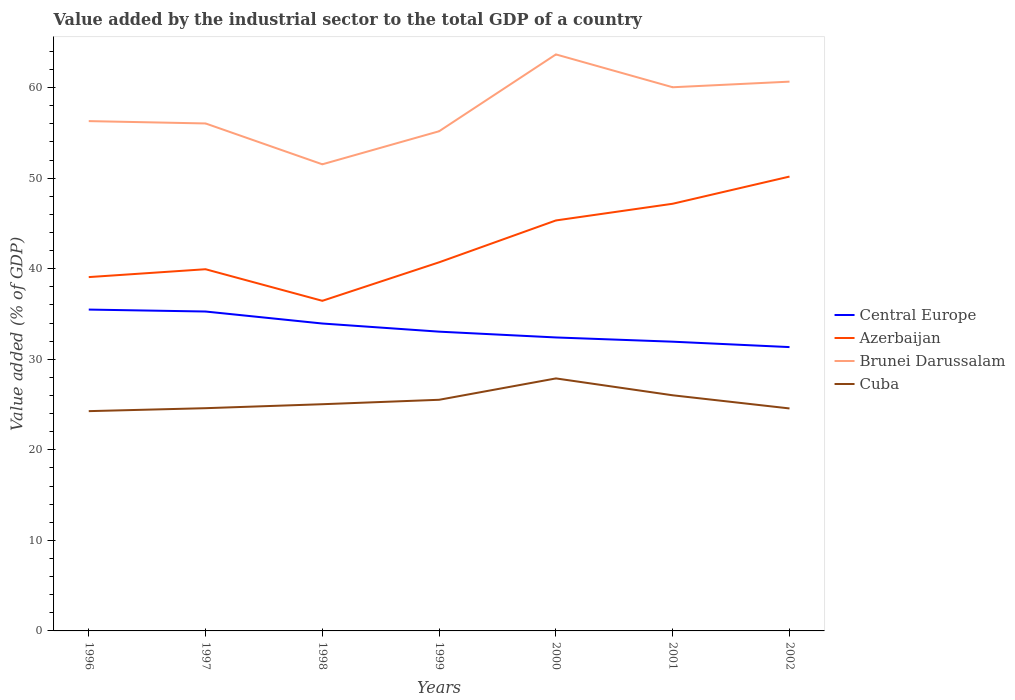Does the line corresponding to Brunei Darussalam intersect with the line corresponding to Central Europe?
Your answer should be compact. No. Across all years, what is the maximum value added by the industrial sector to the total GDP in Central Europe?
Your answer should be compact. 31.35. In which year was the value added by the industrial sector to the total GDP in Azerbaijan maximum?
Your answer should be very brief. 1998. What is the total value added by the industrial sector to the total GDP in Brunei Darussalam in the graph?
Ensure brevity in your answer.  4.77. What is the difference between the highest and the second highest value added by the industrial sector to the total GDP in Azerbaijan?
Offer a terse response. 13.72. What is the difference between the highest and the lowest value added by the industrial sector to the total GDP in Brunei Darussalam?
Provide a succinct answer. 3. Is the value added by the industrial sector to the total GDP in Brunei Darussalam strictly greater than the value added by the industrial sector to the total GDP in Cuba over the years?
Your response must be concise. No. What is the difference between two consecutive major ticks on the Y-axis?
Give a very brief answer. 10. Does the graph contain grids?
Ensure brevity in your answer.  No. Where does the legend appear in the graph?
Keep it short and to the point. Center right. How are the legend labels stacked?
Provide a short and direct response. Vertical. What is the title of the graph?
Provide a succinct answer. Value added by the industrial sector to the total GDP of a country. Does "United States" appear as one of the legend labels in the graph?
Offer a very short reply. No. What is the label or title of the X-axis?
Make the answer very short. Years. What is the label or title of the Y-axis?
Offer a very short reply. Value added (% of GDP). What is the Value added (% of GDP) of Central Europe in 1996?
Give a very brief answer. 35.49. What is the Value added (% of GDP) of Azerbaijan in 1996?
Give a very brief answer. 39.08. What is the Value added (% of GDP) of Brunei Darussalam in 1996?
Offer a very short reply. 56.3. What is the Value added (% of GDP) of Cuba in 1996?
Offer a very short reply. 24.27. What is the Value added (% of GDP) in Central Europe in 1997?
Offer a very short reply. 35.27. What is the Value added (% of GDP) in Azerbaijan in 1997?
Ensure brevity in your answer.  39.95. What is the Value added (% of GDP) in Brunei Darussalam in 1997?
Provide a short and direct response. 56.05. What is the Value added (% of GDP) of Cuba in 1997?
Ensure brevity in your answer.  24.6. What is the Value added (% of GDP) in Central Europe in 1998?
Offer a terse response. 33.95. What is the Value added (% of GDP) of Azerbaijan in 1998?
Provide a short and direct response. 36.46. What is the Value added (% of GDP) of Brunei Darussalam in 1998?
Provide a succinct answer. 51.53. What is the Value added (% of GDP) of Cuba in 1998?
Offer a very short reply. 25.04. What is the Value added (% of GDP) of Central Europe in 1999?
Your response must be concise. 33.05. What is the Value added (% of GDP) of Azerbaijan in 1999?
Give a very brief answer. 40.71. What is the Value added (% of GDP) of Brunei Darussalam in 1999?
Give a very brief answer. 55.18. What is the Value added (% of GDP) of Cuba in 1999?
Offer a terse response. 25.53. What is the Value added (% of GDP) in Central Europe in 2000?
Make the answer very short. 32.41. What is the Value added (% of GDP) of Azerbaijan in 2000?
Offer a terse response. 45.33. What is the Value added (% of GDP) of Brunei Darussalam in 2000?
Provide a short and direct response. 63.67. What is the Value added (% of GDP) in Cuba in 2000?
Provide a succinct answer. 27.89. What is the Value added (% of GDP) of Central Europe in 2001?
Provide a succinct answer. 31.94. What is the Value added (% of GDP) of Azerbaijan in 2001?
Your response must be concise. 47.18. What is the Value added (% of GDP) of Brunei Darussalam in 2001?
Keep it short and to the point. 60.04. What is the Value added (% of GDP) of Cuba in 2001?
Provide a succinct answer. 26.02. What is the Value added (% of GDP) in Central Europe in 2002?
Offer a very short reply. 31.35. What is the Value added (% of GDP) in Azerbaijan in 2002?
Offer a very short reply. 50.18. What is the Value added (% of GDP) of Brunei Darussalam in 2002?
Your answer should be very brief. 60.66. What is the Value added (% of GDP) in Cuba in 2002?
Provide a succinct answer. 24.57. Across all years, what is the maximum Value added (% of GDP) in Central Europe?
Give a very brief answer. 35.49. Across all years, what is the maximum Value added (% of GDP) in Azerbaijan?
Your response must be concise. 50.18. Across all years, what is the maximum Value added (% of GDP) of Brunei Darussalam?
Make the answer very short. 63.67. Across all years, what is the maximum Value added (% of GDP) in Cuba?
Offer a terse response. 27.89. Across all years, what is the minimum Value added (% of GDP) in Central Europe?
Your answer should be very brief. 31.35. Across all years, what is the minimum Value added (% of GDP) of Azerbaijan?
Provide a succinct answer. 36.46. Across all years, what is the minimum Value added (% of GDP) in Brunei Darussalam?
Provide a short and direct response. 51.53. Across all years, what is the minimum Value added (% of GDP) of Cuba?
Your response must be concise. 24.27. What is the total Value added (% of GDP) of Central Europe in the graph?
Offer a terse response. 233.47. What is the total Value added (% of GDP) of Azerbaijan in the graph?
Your answer should be very brief. 298.88. What is the total Value added (% of GDP) of Brunei Darussalam in the graph?
Give a very brief answer. 403.44. What is the total Value added (% of GDP) of Cuba in the graph?
Provide a succinct answer. 177.92. What is the difference between the Value added (% of GDP) in Central Europe in 1996 and that in 1997?
Your answer should be compact. 0.21. What is the difference between the Value added (% of GDP) of Azerbaijan in 1996 and that in 1997?
Ensure brevity in your answer.  -0.87. What is the difference between the Value added (% of GDP) of Brunei Darussalam in 1996 and that in 1997?
Provide a succinct answer. 0.26. What is the difference between the Value added (% of GDP) in Cuba in 1996 and that in 1997?
Offer a very short reply. -0.33. What is the difference between the Value added (% of GDP) of Central Europe in 1996 and that in 1998?
Ensure brevity in your answer.  1.54. What is the difference between the Value added (% of GDP) in Azerbaijan in 1996 and that in 1998?
Your response must be concise. 2.62. What is the difference between the Value added (% of GDP) of Brunei Darussalam in 1996 and that in 1998?
Ensure brevity in your answer.  4.77. What is the difference between the Value added (% of GDP) of Cuba in 1996 and that in 1998?
Offer a very short reply. -0.76. What is the difference between the Value added (% of GDP) of Central Europe in 1996 and that in 1999?
Ensure brevity in your answer.  2.44. What is the difference between the Value added (% of GDP) of Azerbaijan in 1996 and that in 1999?
Your answer should be compact. -1.63. What is the difference between the Value added (% of GDP) of Brunei Darussalam in 1996 and that in 1999?
Your response must be concise. 1.12. What is the difference between the Value added (% of GDP) of Cuba in 1996 and that in 1999?
Your answer should be very brief. -1.26. What is the difference between the Value added (% of GDP) in Central Europe in 1996 and that in 2000?
Offer a very short reply. 3.08. What is the difference between the Value added (% of GDP) in Azerbaijan in 1996 and that in 2000?
Your response must be concise. -6.26. What is the difference between the Value added (% of GDP) of Brunei Darussalam in 1996 and that in 2000?
Keep it short and to the point. -7.37. What is the difference between the Value added (% of GDP) of Cuba in 1996 and that in 2000?
Give a very brief answer. -3.61. What is the difference between the Value added (% of GDP) of Central Europe in 1996 and that in 2001?
Offer a terse response. 3.55. What is the difference between the Value added (% of GDP) of Azerbaijan in 1996 and that in 2001?
Offer a terse response. -8.1. What is the difference between the Value added (% of GDP) in Brunei Darussalam in 1996 and that in 2001?
Offer a terse response. -3.74. What is the difference between the Value added (% of GDP) in Cuba in 1996 and that in 2001?
Keep it short and to the point. -1.75. What is the difference between the Value added (% of GDP) in Central Europe in 1996 and that in 2002?
Provide a succinct answer. 4.14. What is the difference between the Value added (% of GDP) of Azerbaijan in 1996 and that in 2002?
Offer a terse response. -11.1. What is the difference between the Value added (% of GDP) in Brunei Darussalam in 1996 and that in 2002?
Your answer should be compact. -4.36. What is the difference between the Value added (% of GDP) in Cuba in 1996 and that in 2002?
Provide a short and direct response. -0.3. What is the difference between the Value added (% of GDP) in Central Europe in 1997 and that in 1998?
Your answer should be compact. 1.33. What is the difference between the Value added (% of GDP) of Azerbaijan in 1997 and that in 1998?
Ensure brevity in your answer.  3.49. What is the difference between the Value added (% of GDP) of Brunei Darussalam in 1997 and that in 1998?
Your answer should be compact. 4.51. What is the difference between the Value added (% of GDP) of Cuba in 1997 and that in 1998?
Give a very brief answer. -0.44. What is the difference between the Value added (% of GDP) of Central Europe in 1997 and that in 1999?
Provide a short and direct response. 2.22. What is the difference between the Value added (% of GDP) of Azerbaijan in 1997 and that in 1999?
Your response must be concise. -0.77. What is the difference between the Value added (% of GDP) in Brunei Darussalam in 1997 and that in 1999?
Make the answer very short. 0.86. What is the difference between the Value added (% of GDP) in Cuba in 1997 and that in 1999?
Your answer should be compact. -0.93. What is the difference between the Value added (% of GDP) of Central Europe in 1997 and that in 2000?
Provide a succinct answer. 2.86. What is the difference between the Value added (% of GDP) in Azerbaijan in 1997 and that in 2000?
Make the answer very short. -5.39. What is the difference between the Value added (% of GDP) in Brunei Darussalam in 1997 and that in 2000?
Make the answer very short. -7.62. What is the difference between the Value added (% of GDP) in Cuba in 1997 and that in 2000?
Provide a succinct answer. -3.29. What is the difference between the Value added (% of GDP) of Central Europe in 1997 and that in 2001?
Provide a short and direct response. 3.33. What is the difference between the Value added (% of GDP) in Azerbaijan in 1997 and that in 2001?
Provide a short and direct response. -7.23. What is the difference between the Value added (% of GDP) of Brunei Darussalam in 1997 and that in 2001?
Give a very brief answer. -4. What is the difference between the Value added (% of GDP) of Cuba in 1997 and that in 2001?
Offer a terse response. -1.43. What is the difference between the Value added (% of GDP) in Central Europe in 1997 and that in 2002?
Offer a terse response. 3.93. What is the difference between the Value added (% of GDP) of Azerbaijan in 1997 and that in 2002?
Make the answer very short. -10.23. What is the difference between the Value added (% of GDP) in Brunei Darussalam in 1997 and that in 2002?
Give a very brief answer. -4.62. What is the difference between the Value added (% of GDP) in Cuba in 1997 and that in 2002?
Make the answer very short. 0.03. What is the difference between the Value added (% of GDP) in Central Europe in 1998 and that in 1999?
Offer a terse response. 0.9. What is the difference between the Value added (% of GDP) of Azerbaijan in 1998 and that in 1999?
Provide a short and direct response. -4.25. What is the difference between the Value added (% of GDP) in Brunei Darussalam in 1998 and that in 1999?
Offer a very short reply. -3.65. What is the difference between the Value added (% of GDP) of Cuba in 1998 and that in 1999?
Your response must be concise. -0.49. What is the difference between the Value added (% of GDP) in Central Europe in 1998 and that in 2000?
Make the answer very short. 1.54. What is the difference between the Value added (% of GDP) of Azerbaijan in 1998 and that in 2000?
Offer a terse response. -8.88. What is the difference between the Value added (% of GDP) in Brunei Darussalam in 1998 and that in 2000?
Give a very brief answer. -12.14. What is the difference between the Value added (% of GDP) of Cuba in 1998 and that in 2000?
Offer a terse response. -2.85. What is the difference between the Value added (% of GDP) in Central Europe in 1998 and that in 2001?
Keep it short and to the point. 2.01. What is the difference between the Value added (% of GDP) of Azerbaijan in 1998 and that in 2001?
Make the answer very short. -10.72. What is the difference between the Value added (% of GDP) in Brunei Darussalam in 1998 and that in 2001?
Make the answer very short. -8.51. What is the difference between the Value added (% of GDP) in Cuba in 1998 and that in 2001?
Your answer should be compact. -0.99. What is the difference between the Value added (% of GDP) of Central Europe in 1998 and that in 2002?
Provide a succinct answer. 2.6. What is the difference between the Value added (% of GDP) of Azerbaijan in 1998 and that in 2002?
Provide a succinct answer. -13.72. What is the difference between the Value added (% of GDP) of Brunei Darussalam in 1998 and that in 2002?
Ensure brevity in your answer.  -9.13. What is the difference between the Value added (% of GDP) of Cuba in 1998 and that in 2002?
Ensure brevity in your answer.  0.47. What is the difference between the Value added (% of GDP) in Central Europe in 1999 and that in 2000?
Make the answer very short. 0.64. What is the difference between the Value added (% of GDP) in Azerbaijan in 1999 and that in 2000?
Make the answer very short. -4.62. What is the difference between the Value added (% of GDP) in Brunei Darussalam in 1999 and that in 2000?
Your answer should be compact. -8.49. What is the difference between the Value added (% of GDP) in Cuba in 1999 and that in 2000?
Provide a succinct answer. -2.36. What is the difference between the Value added (% of GDP) of Central Europe in 1999 and that in 2001?
Provide a short and direct response. 1.11. What is the difference between the Value added (% of GDP) of Azerbaijan in 1999 and that in 2001?
Make the answer very short. -6.47. What is the difference between the Value added (% of GDP) in Brunei Darussalam in 1999 and that in 2001?
Offer a very short reply. -4.86. What is the difference between the Value added (% of GDP) in Cuba in 1999 and that in 2001?
Offer a terse response. -0.5. What is the difference between the Value added (% of GDP) in Central Europe in 1999 and that in 2002?
Offer a terse response. 1.7. What is the difference between the Value added (% of GDP) in Azerbaijan in 1999 and that in 2002?
Your answer should be compact. -9.47. What is the difference between the Value added (% of GDP) of Brunei Darussalam in 1999 and that in 2002?
Provide a short and direct response. -5.48. What is the difference between the Value added (% of GDP) in Cuba in 1999 and that in 2002?
Your answer should be very brief. 0.96. What is the difference between the Value added (% of GDP) of Central Europe in 2000 and that in 2001?
Your answer should be compact. 0.47. What is the difference between the Value added (% of GDP) of Azerbaijan in 2000 and that in 2001?
Make the answer very short. -1.84. What is the difference between the Value added (% of GDP) of Brunei Darussalam in 2000 and that in 2001?
Give a very brief answer. 3.63. What is the difference between the Value added (% of GDP) in Cuba in 2000 and that in 2001?
Provide a short and direct response. 1.86. What is the difference between the Value added (% of GDP) in Central Europe in 2000 and that in 2002?
Offer a terse response. 1.06. What is the difference between the Value added (% of GDP) in Azerbaijan in 2000 and that in 2002?
Ensure brevity in your answer.  -4.85. What is the difference between the Value added (% of GDP) in Brunei Darussalam in 2000 and that in 2002?
Offer a very short reply. 3.01. What is the difference between the Value added (% of GDP) of Cuba in 2000 and that in 2002?
Ensure brevity in your answer.  3.32. What is the difference between the Value added (% of GDP) in Central Europe in 2001 and that in 2002?
Give a very brief answer. 0.6. What is the difference between the Value added (% of GDP) of Azerbaijan in 2001 and that in 2002?
Offer a very short reply. -3. What is the difference between the Value added (% of GDP) in Brunei Darussalam in 2001 and that in 2002?
Give a very brief answer. -0.62. What is the difference between the Value added (% of GDP) of Cuba in 2001 and that in 2002?
Make the answer very short. 1.45. What is the difference between the Value added (% of GDP) in Central Europe in 1996 and the Value added (% of GDP) in Azerbaijan in 1997?
Give a very brief answer. -4.46. What is the difference between the Value added (% of GDP) in Central Europe in 1996 and the Value added (% of GDP) in Brunei Darussalam in 1997?
Your answer should be very brief. -20.56. What is the difference between the Value added (% of GDP) of Central Europe in 1996 and the Value added (% of GDP) of Cuba in 1997?
Offer a very short reply. 10.89. What is the difference between the Value added (% of GDP) of Azerbaijan in 1996 and the Value added (% of GDP) of Brunei Darussalam in 1997?
Your answer should be very brief. -16.97. What is the difference between the Value added (% of GDP) of Azerbaijan in 1996 and the Value added (% of GDP) of Cuba in 1997?
Give a very brief answer. 14.48. What is the difference between the Value added (% of GDP) in Brunei Darussalam in 1996 and the Value added (% of GDP) in Cuba in 1997?
Your response must be concise. 31.71. What is the difference between the Value added (% of GDP) in Central Europe in 1996 and the Value added (% of GDP) in Azerbaijan in 1998?
Provide a short and direct response. -0.97. What is the difference between the Value added (% of GDP) of Central Europe in 1996 and the Value added (% of GDP) of Brunei Darussalam in 1998?
Provide a short and direct response. -16.04. What is the difference between the Value added (% of GDP) in Central Europe in 1996 and the Value added (% of GDP) in Cuba in 1998?
Your response must be concise. 10.45. What is the difference between the Value added (% of GDP) in Azerbaijan in 1996 and the Value added (% of GDP) in Brunei Darussalam in 1998?
Offer a very short reply. -12.46. What is the difference between the Value added (% of GDP) in Azerbaijan in 1996 and the Value added (% of GDP) in Cuba in 1998?
Make the answer very short. 14.04. What is the difference between the Value added (% of GDP) in Brunei Darussalam in 1996 and the Value added (% of GDP) in Cuba in 1998?
Offer a terse response. 31.27. What is the difference between the Value added (% of GDP) of Central Europe in 1996 and the Value added (% of GDP) of Azerbaijan in 1999?
Provide a short and direct response. -5.22. What is the difference between the Value added (% of GDP) of Central Europe in 1996 and the Value added (% of GDP) of Brunei Darussalam in 1999?
Provide a succinct answer. -19.69. What is the difference between the Value added (% of GDP) in Central Europe in 1996 and the Value added (% of GDP) in Cuba in 1999?
Ensure brevity in your answer.  9.96. What is the difference between the Value added (% of GDP) in Azerbaijan in 1996 and the Value added (% of GDP) in Brunei Darussalam in 1999?
Offer a very short reply. -16.11. What is the difference between the Value added (% of GDP) in Azerbaijan in 1996 and the Value added (% of GDP) in Cuba in 1999?
Your answer should be very brief. 13.55. What is the difference between the Value added (% of GDP) in Brunei Darussalam in 1996 and the Value added (% of GDP) in Cuba in 1999?
Provide a succinct answer. 30.78. What is the difference between the Value added (% of GDP) of Central Europe in 1996 and the Value added (% of GDP) of Azerbaijan in 2000?
Keep it short and to the point. -9.84. What is the difference between the Value added (% of GDP) in Central Europe in 1996 and the Value added (% of GDP) in Brunei Darussalam in 2000?
Your answer should be very brief. -28.18. What is the difference between the Value added (% of GDP) of Central Europe in 1996 and the Value added (% of GDP) of Cuba in 2000?
Provide a succinct answer. 7.6. What is the difference between the Value added (% of GDP) of Azerbaijan in 1996 and the Value added (% of GDP) of Brunei Darussalam in 2000?
Keep it short and to the point. -24.59. What is the difference between the Value added (% of GDP) of Azerbaijan in 1996 and the Value added (% of GDP) of Cuba in 2000?
Your response must be concise. 11.19. What is the difference between the Value added (% of GDP) of Brunei Darussalam in 1996 and the Value added (% of GDP) of Cuba in 2000?
Your answer should be compact. 28.42. What is the difference between the Value added (% of GDP) in Central Europe in 1996 and the Value added (% of GDP) in Azerbaijan in 2001?
Ensure brevity in your answer.  -11.69. What is the difference between the Value added (% of GDP) of Central Europe in 1996 and the Value added (% of GDP) of Brunei Darussalam in 2001?
Offer a very short reply. -24.55. What is the difference between the Value added (% of GDP) in Central Europe in 1996 and the Value added (% of GDP) in Cuba in 2001?
Provide a short and direct response. 9.47. What is the difference between the Value added (% of GDP) of Azerbaijan in 1996 and the Value added (% of GDP) of Brunei Darussalam in 2001?
Give a very brief answer. -20.97. What is the difference between the Value added (% of GDP) in Azerbaijan in 1996 and the Value added (% of GDP) in Cuba in 2001?
Make the answer very short. 13.05. What is the difference between the Value added (% of GDP) of Brunei Darussalam in 1996 and the Value added (% of GDP) of Cuba in 2001?
Your answer should be compact. 30.28. What is the difference between the Value added (% of GDP) in Central Europe in 1996 and the Value added (% of GDP) in Azerbaijan in 2002?
Ensure brevity in your answer.  -14.69. What is the difference between the Value added (% of GDP) of Central Europe in 1996 and the Value added (% of GDP) of Brunei Darussalam in 2002?
Provide a succinct answer. -25.17. What is the difference between the Value added (% of GDP) of Central Europe in 1996 and the Value added (% of GDP) of Cuba in 2002?
Ensure brevity in your answer.  10.92. What is the difference between the Value added (% of GDP) in Azerbaijan in 1996 and the Value added (% of GDP) in Brunei Darussalam in 2002?
Ensure brevity in your answer.  -21.58. What is the difference between the Value added (% of GDP) of Azerbaijan in 1996 and the Value added (% of GDP) of Cuba in 2002?
Provide a short and direct response. 14.51. What is the difference between the Value added (% of GDP) in Brunei Darussalam in 1996 and the Value added (% of GDP) in Cuba in 2002?
Keep it short and to the point. 31.73. What is the difference between the Value added (% of GDP) of Central Europe in 1997 and the Value added (% of GDP) of Azerbaijan in 1998?
Offer a terse response. -1.18. What is the difference between the Value added (% of GDP) of Central Europe in 1997 and the Value added (% of GDP) of Brunei Darussalam in 1998?
Provide a short and direct response. -16.26. What is the difference between the Value added (% of GDP) in Central Europe in 1997 and the Value added (% of GDP) in Cuba in 1998?
Give a very brief answer. 10.24. What is the difference between the Value added (% of GDP) of Azerbaijan in 1997 and the Value added (% of GDP) of Brunei Darussalam in 1998?
Provide a succinct answer. -11.59. What is the difference between the Value added (% of GDP) in Azerbaijan in 1997 and the Value added (% of GDP) in Cuba in 1998?
Give a very brief answer. 14.91. What is the difference between the Value added (% of GDP) of Brunei Darussalam in 1997 and the Value added (% of GDP) of Cuba in 1998?
Provide a succinct answer. 31.01. What is the difference between the Value added (% of GDP) in Central Europe in 1997 and the Value added (% of GDP) in Azerbaijan in 1999?
Make the answer very short. -5.44. What is the difference between the Value added (% of GDP) of Central Europe in 1997 and the Value added (% of GDP) of Brunei Darussalam in 1999?
Give a very brief answer. -19.91. What is the difference between the Value added (% of GDP) of Central Europe in 1997 and the Value added (% of GDP) of Cuba in 1999?
Give a very brief answer. 9.75. What is the difference between the Value added (% of GDP) in Azerbaijan in 1997 and the Value added (% of GDP) in Brunei Darussalam in 1999?
Provide a short and direct response. -15.24. What is the difference between the Value added (% of GDP) of Azerbaijan in 1997 and the Value added (% of GDP) of Cuba in 1999?
Ensure brevity in your answer.  14.42. What is the difference between the Value added (% of GDP) of Brunei Darussalam in 1997 and the Value added (% of GDP) of Cuba in 1999?
Ensure brevity in your answer.  30.52. What is the difference between the Value added (% of GDP) of Central Europe in 1997 and the Value added (% of GDP) of Azerbaijan in 2000?
Provide a short and direct response. -10.06. What is the difference between the Value added (% of GDP) in Central Europe in 1997 and the Value added (% of GDP) in Brunei Darussalam in 2000?
Ensure brevity in your answer.  -28.39. What is the difference between the Value added (% of GDP) of Central Europe in 1997 and the Value added (% of GDP) of Cuba in 2000?
Give a very brief answer. 7.39. What is the difference between the Value added (% of GDP) of Azerbaijan in 1997 and the Value added (% of GDP) of Brunei Darussalam in 2000?
Keep it short and to the point. -23.72. What is the difference between the Value added (% of GDP) in Azerbaijan in 1997 and the Value added (% of GDP) in Cuba in 2000?
Offer a terse response. 12.06. What is the difference between the Value added (% of GDP) of Brunei Darussalam in 1997 and the Value added (% of GDP) of Cuba in 2000?
Make the answer very short. 28.16. What is the difference between the Value added (% of GDP) in Central Europe in 1997 and the Value added (% of GDP) in Azerbaijan in 2001?
Your answer should be compact. -11.9. What is the difference between the Value added (% of GDP) in Central Europe in 1997 and the Value added (% of GDP) in Brunei Darussalam in 2001?
Ensure brevity in your answer.  -24.77. What is the difference between the Value added (% of GDP) in Central Europe in 1997 and the Value added (% of GDP) in Cuba in 2001?
Keep it short and to the point. 9.25. What is the difference between the Value added (% of GDP) in Azerbaijan in 1997 and the Value added (% of GDP) in Brunei Darussalam in 2001?
Make the answer very short. -20.1. What is the difference between the Value added (% of GDP) of Azerbaijan in 1997 and the Value added (% of GDP) of Cuba in 2001?
Your response must be concise. 13.92. What is the difference between the Value added (% of GDP) of Brunei Darussalam in 1997 and the Value added (% of GDP) of Cuba in 2001?
Your response must be concise. 30.02. What is the difference between the Value added (% of GDP) in Central Europe in 1997 and the Value added (% of GDP) in Azerbaijan in 2002?
Your answer should be compact. -14.9. What is the difference between the Value added (% of GDP) in Central Europe in 1997 and the Value added (% of GDP) in Brunei Darussalam in 2002?
Give a very brief answer. -25.39. What is the difference between the Value added (% of GDP) of Central Europe in 1997 and the Value added (% of GDP) of Cuba in 2002?
Provide a succinct answer. 10.7. What is the difference between the Value added (% of GDP) of Azerbaijan in 1997 and the Value added (% of GDP) of Brunei Darussalam in 2002?
Provide a short and direct response. -20.72. What is the difference between the Value added (% of GDP) of Azerbaijan in 1997 and the Value added (% of GDP) of Cuba in 2002?
Ensure brevity in your answer.  15.38. What is the difference between the Value added (% of GDP) in Brunei Darussalam in 1997 and the Value added (% of GDP) in Cuba in 2002?
Your response must be concise. 31.48. What is the difference between the Value added (% of GDP) of Central Europe in 1998 and the Value added (% of GDP) of Azerbaijan in 1999?
Provide a short and direct response. -6.76. What is the difference between the Value added (% of GDP) in Central Europe in 1998 and the Value added (% of GDP) in Brunei Darussalam in 1999?
Your answer should be very brief. -21.23. What is the difference between the Value added (% of GDP) of Central Europe in 1998 and the Value added (% of GDP) of Cuba in 1999?
Ensure brevity in your answer.  8.42. What is the difference between the Value added (% of GDP) in Azerbaijan in 1998 and the Value added (% of GDP) in Brunei Darussalam in 1999?
Your response must be concise. -18.73. What is the difference between the Value added (% of GDP) in Azerbaijan in 1998 and the Value added (% of GDP) in Cuba in 1999?
Offer a terse response. 10.93. What is the difference between the Value added (% of GDP) in Brunei Darussalam in 1998 and the Value added (% of GDP) in Cuba in 1999?
Give a very brief answer. 26.01. What is the difference between the Value added (% of GDP) in Central Europe in 1998 and the Value added (% of GDP) in Azerbaijan in 2000?
Make the answer very short. -11.38. What is the difference between the Value added (% of GDP) in Central Europe in 1998 and the Value added (% of GDP) in Brunei Darussalam in 2000?
Keep it short and to the point. -29.72. What is the difference between the Value added (% of GDP) of Central Europe in 1998 and the Value added (% of GDP) of Cuba in 2000?
Offer a terse response. 6.06. What is the difference between the Value added (% of GDP) of Azerbaijan in 1998 and the Value added (% of GDP) of Brunei Darussalam in 2000?
Offer a very short reply. -27.21. What is the difference between the Value added (% of GDP) of Azerbaijan in 1998 and the Value added (% of GDP) of Cuba in 2000?
Keep it short and to the point. 8.57. What is the difference between the Value added (% of GDP) of Brunei Darussalam in 1998 and the Value added (% of GDP) of Cuba in 2000?
Keep it short and to the point. 23.65. What is the difference between the Value added (% of GDP) in Central Europe in 1998 and the Value added (% of GDP) in Azerbaijan in 2001?
Keep it short and to the point. -13.23. What is the difference between the Value added (% of GDP) in Central Europe in 1998 and the Value added (% of GDP) in Brunei Darussalam in 2001?
Keep it short and to the point. -26.09. What is the difference between the Value added (% of GDP) in Central Europe in 1998 and the Value added (% of GDP) in Cuba in 2001?
Your answer should be very brief. 7.93. What is the difference between the Value added (% of GDP) of Azerbaijan in 1998 and the Value added (% of GDP) of Brunei Darussalam in 2001?
Offer a very short reply. -23.59. What is the difference between the Value added (% of GDP) in Azerbaijan in 1998 and the Value added (% of GDP) in Cuba in 2001?
Keep it short and to the point. 10.43. What is the difference between the Value added (% of GDP) of Brunei Darussalam in 1998 and the Value added (% of GDP) of Cuba in 2001?
Offer a very short reply. 25.51. What is the difference between the Value added (% of GDP) of Central Europe in 1998 and the Value added (% of GDP) of Azerbaijan in 2002?
Keep it short and to the point. -16.23. What is the difference between the Value added (% of GDP) in Central Europe in 1998 and the Value added (% of GDP) in Brunei Darussalam in 2002?
Provide a short and direct response. -26.71. What is the difference between the Value added (% of GDP) in Central Europe in 1998 and the Value added (% of GDP) in Cuba in 2002?
Provide a short and direct response. 9.38. What is the difference between the Value added (% of GDP) in Azerbaijan in 1998 and the Value added (% of GDP) in Brunei Darussalam in 2002?
Ensure brevity in your answer.  -24.21. What is the difference between the Value added (% of GDP) of Azerbaijan in 1998 and the Value added (% of GDP) of Cuba in 2002?
Make the answer very short. 11.89. What is the difference between the Value added (% of GDP) of Brunei Darussalam in 1998 and the Value added (% of GDP) of Cuba in 2002?
Provide a short and direct response. 26.96. What is the difference between the Value added (% of GDP) of Central Europe in 1999 and the Value added (% of GDP) of Azerbaijan in 2000?
Your answer should be compact. -12.28. What is the difference between the Value added (% of GDP) of Central Europe in 1999 and the Value added (% of GDP) of Brunei Darussalam in 2000?
Make the answer very short. -30.62. What is the difference between the Value added (% of GDP) of Central Europe in 1999 and the Value added (% of GDP) of Cuba in 2000?
Keep it short and to the point. 5.16. What is the difference between the Value added (% of GDP) of Azerbaijan in 1999 and the Value added (% of GDP) of Brunei Darussalam in 2000?
Offer a terse response. -22.96. What is the difference between the Value added (% of GDP) in Azerbaijan in 1999 and the Value added (% of GDP) in Cuba in 2000?
Provide a succinct answer. 12.82. What is the difference between the Value added (% of GDP) in Brunei Darussalam in 1999 and the Value added (% of GDP) in Cuba in 2000?
Ensure brevity in your answer.  27.3. What is the difference between the Value added (% of GDP) in Central Europe in 1999 and the Value added (% of GDP) in Azerbaijan in 2001?
Make the answer very short. -14.13. What is the difference between the Value added (% of GDP) in Central Europe in 1999 and the Value added (% of GDP) in Brunei Darussalam in 2001?
Provide a succinct answer. -26.99. What is the difference between the Value added (% of GDP) in Central Europe in 1999 and the Value added (% of GDP) in Cuba in 2001?
Ensure brevity in your answer.  7.03. What is the difference between the Value added (% of GDP) in Azerbaijan in 1999 and the Value added (% of GDP) in Brunei Darussalam in 2001?
Offer a terse response. -19.33. What is the difference between the Value added (% of GDP) of Azerbaijan in 1999 and the Value added (% of GDP) of Cuba in 2001?
Offer a very short reply. 14.69. What is the difference between the Value added (% of GDP) in Brunei Darussalam in 1999 and the Value added (% of GDP) in Cuba in 2001?
Offer a terse response. 29.16. What is the difference between the Value added (% of GDP) of Central Europe in 1999 and the Value added (% of GDP) of Azerbaijan in 2002?
Make the answer very short. -17.13. What is the difference between the Value added (% of GDP) of Central Europe in 1999 and the Value added (% of GDP) of Brunei Darussalam in 2002?
Offer a terse response. -27.61. What is the difference between the Value added (% of GDP) of Central Europe in 1999 and the Value added (% of GDP) of Cuba in 2002?
Provide a succinct answer. 8.48. What is the difference between the Value added (% of GDP) of Azerbaijan in 1999 and the Value added (% of GDP) of Brunei Darussalam in 2002?
Your answer should be very brief. -19.95. What is the difference between the Value added (% of GDP) of Azerbaijan in 1999 and the Value added (% of GDP) of Cuba in 2002?
Make the answer very short. 16.14. What is the difference between the Value added (% of GDP) of Brunei Darussalam in 1999 and the Value added (% of GDP) of Cuba in 2002?
Keep it short and to the point. 30.61. What is the difference between the Value added (% of GDP) of Central Europe in 2000 and the Value added (% of GDP) of Azerbaijan in 2001?
Your response must be concise. -14.77. What is the difference between the Value added (% of GDP) of Central Europe in 2000 and the Value added (% of GDP) of Brunei Darussalam in 2001?
Your answer should be very brief. -27.63. What is the difference between the Value added (% of GDP) in Central Europe in 2000 and the Value added (% of GDP) in Cuba in 2001?
Provide a short and direct response. 6.39. What is the difference between the Value added (% of GDP) of Azerbaijan in 2000 and the Value added (% of GDP) of Brunei Darussalam in 2001?
Keep it short and to the point. -14.71. What is the difference between the Value added (% of GDP) of Azerbaijan in 2000 and the Value added (% of GDP) of Cuba in 2001?
Provide a short and direct response. 19.31. What is the difference between the Value added (% of GDP) in Brunei Darussalam in 2000 and the Value added (% of GDP) in Cuba in 2001?
Make the answer very short. 37.65. What is the difference between the Value added (% of GDP) in Central Europe in 2000 and the Value added (% of GDP) in Azerbaijan in 2002?
Your answer should be very brief. -17.77. What is the difference between the Value added (% of GDP) of Central Europe in 2000 and the Value added (% of GDP) of Brunei Darussalam in 2002?
Provide a short and direct response. -28.25. What is the difference between the Value added (% of GDP) in Central Europe in 2000 and the Value added (% of GDP) in Cuba in 2002?
Provide a succinct answer. 7.84. What is the difference between the Value added (% of GDP) of Azerbaijan in 2000 and the Value added (% of GDP) of Brunei Darussalam in 2002?
Give a very brief answer. -15.33. What is the difference between the Value added (% of GDP) in Azerbaijan in 2000 and the Value added (% of GDP) in Cuba in 2002?
Give a very brief answer. 20.76. What is the difference between the Value added (% of GDP) in Brunei Darussalam in 2000 and the Value added (% of GDP) in Cuba in 2002?
Offer a very short reply. 39.1. What is the difference between the Value added (% of GDP) of Central Europe in 2001 and the Value added (% of GDP) of Azerbaijan in 2002?
Offer a terse response. -18.23. What is the difference between the Value added (% of GDP) of Central Europe in 2001 and the Value added (% of GDP) of Brunei Darussalam in 2002?
Make the answer very short. -28.72. What is the difference between the Value added (% of GDP) of Central Europe in 2001 and the Value added (% of GDP) of Cuba in 2002?
Ensure brevity in your answer.  7.37. What is the difference between the Value added (% of GDP) in Azerbaijan in 2001 and the Value added (% of GDP) in Brunei Darussalam in 2002?
Give a very brief answer. -13.48. What is the difference between the Value added (% of GDP) of Azerbaijan in 2001 and the Value added (% of GDP) of Cuba in 2002?
Your response must be concise. 22.61. What is the difference between the Value added (% of GDP) of Brunei Darussalam in 2001 and the Value added (% of GDP) of Cuba in 2002?
Ensure brevity in your answer.  35.47. What is the average Value added (% of GDP) of Central Europe per year?
Give a very brief answer. 33.35. What is the average Value added (% of GDP) of Azerbaijan per year?
Ensure brevity in your answer.  42.7. What is the average Value added (% of GDP) in Brunei Darussalam per year?
Offer a very short reply. 57.63. What is the average Value added (% of GDP) in Cuba per year?
Make the answer very short. 25.42. In the year 1996, what is the difference between the Value added (% of GDP) in Central Europe and Value added (% of GDP) in Azerbaijan?
Your answer should be very brief. -3.59. In the year 1996, what is the difference between the Value added (% of GDP) in Central Europe and Value added (% of GDP) in Brunei Darussalam?
Provide a succinct answer. -20.81. In the year 1996, what is the difference between the Value added (% of GDP) in Central Europe and Value added (% of GDP) in Cuba?
Keep it short and to the point. 11.22. In the year 1996, what is the difference between the Value added (% of GDP) of Azerbaijan and Value added (% of GDP) of Brunei Darussalam?
Your answer should be compact. -17.23. In the year 1996, what is the difference between the Value added (% of GDP) of Azerbaijan and Value added (% of GDP) of Cuba?
Provide a short and direct response. 14.8. In the year 1996, what is the difference between the Value added (% of GDP) in Brunei Darussalam and Value added (% of GDP) in Cuba?
Provide a succinct answer. 32.03. In the year 1997, what is the difference between the Value added (% of GDP) in Central Europe and Value added (% of GDP) in Azerbaijan?
Your answer should be compact. -4.67. In the year 1997, what is the difference between the Value added (% of GDP) of Central Europe and Value added (% of GDP) of Brunei Darussalam?
Offer a terse response. -20.77. In the year 1997, what is the difference between the Value added (% of GDP) of Central Europe and Value added (% of GDP) of Cuba?
Offer a very short reply. 10.68. In the year 1997, what is the difference between the Value added (% of GDP) of Azerbaijan and Value added (% of GDP) of Brunei Darussalam?
Give a very brief answer. -16.1. In the year 1997, what is the difference between the Value added (% of GDP) in Azerbaijan and Value added (% of GDP) in Cuba?
Your answer should be compact. 15.35. In the year 1997, what is the difference between the Value added (% of GDP) of Brunei Darussalam and Value added (% of GDP) of Cuba?
Offer a very short reply. 31.45. In the year 1998, what is the difference between the Value added (% of GDP) in Central Europe and Value added (% of GDP) in Azerbaijan?
Ensure brevity in your answer.  -2.51. In the year 1998, what is the difference between the Value added (% of GDP) in Central Europe and Value added (% of GDP) in Brunei Darussalam?
Your response must be concise. -17.58. In the year 1998, what is the difference between the Value added (% of GDP) of Central Europe and Value added (% of GDP) of Cuba?
Keep it short and to the point. 8.91. In the year 1998, what is the difference between the Value added (% of GDP) of Azerbaijan and Value added (% of GDP) of Brunei Darussalam?
Offer a terse response. -15.08. In the year 1998, what is the difference between the Value added (% of GDP) in Azerbaijan and Value added (% of GDP) in Cuba?
Keep it short and to the point. 11.42. In the year 1998, what is the difference between the Value added (% of GDP) of Brunei Darussalam and Value added (% of GDP) of Cuba?
Make the answer very short. 26.5. In the year 1999, what is the difference between the Value added (% of GDP) of Central Europe and Value added (% of GDP) of Azerbaijan?
Keep it short and to the point. -7.66. In the year 1999, what is the difference between the Value added (% of GDP) in Central Europe and Value added (% of GDP) in Brunei Darussalam?
Ensure brevity in your answer.  -22.13. In the year 1999, what is the difference between the Value added (% of GDP) of Central Europe and Value added (% of GDP) of Cuba?
Keep it short and to the point. 7.52. In the year 1999, what is the difference between the Value added (% of GDP) in Azerbaijan and Value added (% of GDP) in Brunei Darussalam?
Provide a succinct answer. -14.47. In the year 1999, what is the difference between the Value added (% of GDP) of Azerbaijan and Value added (% of GDP) of Cuba?
Make the answer very short. 15.18. In the year 1999, what is the difference between the Value added (% of GDP) of Brunei Darussalam and Value added (% of GDP) of Cuba?
Provide a succinct answer. 29.66. In the year 2000, what is the difference between the Value added (% of GDP) in Central Europe and Value added (% of GDP) in Azerbaijan?
Provide a succinct answer. -12.92. In the year 2000, what is the difference between the Value added (% of GDP) in Central Europe and Value added (% of GDP) in Brunei Darussalam?
Provide a short and direct response. -31.26. In the year 2000, what is the difference between the Value added (% of GDP) of Central Europe and Value added (% of GDP) of Cuba?
Your answer should be very brief. 4.52. In the year 2000, what is the difference between the Value added (% of GDP) in Azerbaijan and Value added (% of GDP) in Brunei Darussalam?
Offer a terse response. -18.34. In the year 2000, what is the difference between the Value added (% of GDP) of Azerbaijan and Value added (% of GDP) of Cuba?
Keep it short and to the point. 17.45. In the year 2000, what is the difference between the Value added (% of GDP) in Brunei Darussalam and Value added (% of GDP) in Cuba?
Give a very brief answer. 35.78. In the year 2001, what is the difference between the Value added (% of GDP) of Central Europe and Value added (% of GDP) of Azerbaijan?
Offer a very short reply. -15.23. In the year 2001, what is the difference between the Value added (% of GDP) in Central Europe and Value added (% of GDP) in Brunei Darussalam?
Give a very brief answer. -28.1. In the year 2001, what is the difference between the Value added (% of GDP) in Central Europe and Value added (% of GDP) in Cuba?
Your answer should be compact. 5.92. In the year 2001, what is the difference between the Value added (% of GDP) of Azerbaijan and Value added (% of GDP) of Brunei Darussalam?
Ensure brevity in your answer.  -12.86. In the year 2001, what is the difference between the Value added (% of GDP) in Azerbaijan and Value added (% of GDP) in Cuba?
Offer a very short reply. 21.15. In the year 2001, what is the difference between the Value added (% of GDP) of Brunei Darussalam and Value added (% of GDP) of Cuba?
Provide a short and direct response. 34.02. In the year 2002, what is the difference between the Value added (% of GDP) of Central Europe and Value added (% of GDP) of Azerbaijan?
Keep it short and to the point. -18.83. In the year 2002, what is the difference between the Value added (% of GDP) of Central Europe and Value added (% of GDP) of Brunei Darussalam?
Your answer should be very brief. -29.32. In the year 2002, what is the difference between the Value added (% of GDP) in Central Europe and Value added (% of GDP) in Cuba?
Make the answer very short. 6.78. In the year 2002, what is the difference between the Value added (% of GDP) of Azerbaijan and Value added (% of GDP) of Brunei Darussalam?
Make the answer very short. -10.48. In the year 2002, what is the difference between the Value added (% of GDP) in Azerbaijan and Value added (% of GDP) in Cuba?
Give a very brief answer. 25.61. In the year 2002, what is the difference between the Value added (% of GDP) of Brunei Darussalam and Value added (% of GDP) of Cuba?
Provide a succinct answer. 36.09. What is the ratio of the Value added (% of GDP) of Central Europe in 1996 to that in 1997?
Offer a terse response. 1.01. What is the ratio of the Value added (% of GDP) in Azerbaijan in 1996 to that in 1997?
Provide a succinct answer. 0.98. What is the ratio of the Value added (% of GDP) in Brunei Darussalam in 1996 to that in 1997?
Offer a terse response. 1. What is the ratio of the Value added (% of GDP) of Central Europe in 1996 to that in 1998?
Your answer should be very brief. 1.05. What is the ratio of the Value added (% of GDP) of Azerbaijan in 1996 to that in 1998?
Ensure brevity in your answer.  1.07. What is the ratio of the Value added (% of GDP) of Brunei Darussalam in 1996 to that in 1998?
Make the answer very short. 1.09. What is the ratio of the Value added (% of GDP) of Cuba in 1996 to that in 1998?
Offer a terse response. 0.97. What is the ratio of the Value added (% of GDP) in Central Europe in 1996 to that in 1999?
Keep it short and to the point. 1.07. What is the ratio of the Value added (% of GDP) in Azerbaijan in 1996 to that in 1999?
Keep it short and to the point. 0.96. What is the ratio of the Value added (% of GDP) of Brunei Darussalam in 1996 to that in 1999?
Provide a short and direct response. 1.02. What is the ratio of the Value added (% of GDP) of Cuba in 1996 to that in 1999?
Your response must be concise. 0.95. What is the ratio of the Value added (% of GDP) of Central Europe in 1996 to that in 2000?
Provide a succinct answer. 1.09. What is the ratio of the Value added (% of GDP) of Azerbaijan in 1996 to that in 2000?
Keep it short and to the point. 0.86. What is the ratio of the Value added (% of GDP) of Brunei Darussalam in 1996 to that in 2000?
Keep it short and to the point. 0.88. What is the ratio of the Value added (% of GDP) of Cuba in 1996 to that in 2000?
Provide a short and direct response. 0.87. What is the ratio of the Value added (% of GDP) in Central Europe in 1996 to that in 2001?
Give a very brief answer. 1.11. What is the ratio of the Value added (% of GDP) of Azerbaijan in 1996 to that in 2001?
Provide a short and direct response. 0.83. What is the ratio of the Value added (% of GDP) in Brunei Darussalam in 1996 to that in 2001?
Give a very brief answer. 0.94. What is the ratio of the Value added (% of GDP) in Cuba in 1996 to that in 2001?
Your response must be concise. 0.93. What is the ratio of the Value added (% of GDP) in Central Europe in 1996 to that in 2002?
Your answer should be very brief. 1.13. What is the ratio of the Value added (% of GDP) in Azerbaijan in 1996 to that in 2002?
Offer a terse response. 0.78. What is the ratio of the Value added (% of GDP) in Brunei Darussalam in 1996 to that in 2002?
Provide a short and direct response. 0.93. What is the ratio of the Value added (% of GDP) of Cuba in 1996 to that in 2002?
Your answer should be very brief. 0.99. What is the ratio of the Value added (% of GDP) in Central Europe in 1997 to that in 1998?
Your answer should be very brief. 1.04. What is the ratio of the Value added (% of GDP) in Azerbaijan in 1997 to that in 1998?
Offer a very short reply. 1.1. What is the ratio of the Value added (% of GDP) in Brunei Darussalam in 1997 to that in 1998?
Ensure brevity in your answer.  1.09. What is the ratio of the Value added (% of GDP) in Cuba in 1997 to that in 1998?
Your answer should be compact. 0.98. What is the ratio of the Value added (% of GDP) of Central Europe in 1997 to that in 1999?
Give a very brief answer. 1.07. What is the ratio of the Value added (% of GDP) in Azerbaijan in 1997 to that in 1999?
Keep it short and to the point. 0.98. What is the ratio of the Value added (% of GDP) in Brunei Darussalam in 1997 to that in 1999?
Provide a succinct answer. 1.02. What is the ratio of the Value added (% of GDP) in Cuba in 1997 to that in 1999?
Offer a terse response. 0.96. What is the ratio of the Value added (% of GDP) of Central Europe in 1997 to that in 2000?
Ensure brevity in your answer.  1.09. What is the ratio of the Value added (% of GDP) in Azerbaijan in 1997 to that in 2000?
Give a very brief answer. 0.88. What is the ratio of the Value added (% of GDP) in Brunei Darussalam in 1997 to that in 2000?
Your response must be concise. 0.88. What is the ratio of the Value added (% of GDP) in Cuba in 1997 to that in 2000?
Offer a very short reply. 0.88. What is the ratio of the Value added (% of GDP) of Central Europe in 1997 to that in 2001?
Make the answer very short. 1.1. What is the ratio of the Value added (% of GDP) of Azerbaijan in 1997 to that in 2001?
Keep it short and to the point. 0.85. What is the ratio of the Value added (% of GDP) in Brunei Darussalam in 1997 to that in 2001?
Offer a terse response. 0.93. What is the ratio of the Value added (% of GDP) in Cuba in 1997 to that in 2001?
Your response must be concise. 0.95. What is the ratio of the Value added (% of GDP) of Central Europe in 1997 to that in 2002?
Ensure brevity in your answer.  1.13. What is the ratio of the Value added (% of GDP) in Azerbaijan in 1997 to that in 2002?
Provide a short and direct response. 0.8. What is the ratio of the Value added (% of GDP) in Brunei Darussalam in 1997 to that in 2002?
Make the answer very short. 0.92. What is the ratio of the Value added (% of GDP) of Cuba in 1997 to that in 2002?
Offer a terse response. 1. What is the ratio of the Value added (% of GDP) of Central Europe in 1998 to that in 1999?
Give a very brief answer. 1.03. What is the ratio of the Value added (% of GDP) in Azerbaijan in 1998 to that in 1999?
Your answer should be very brief. 0.9. What is the ratio of the Value added (% of GDP) of Brunei Darussalam in 1998 to that in 1999?
Offer a terse response. 0.93. What is the ratio of the Value added (% of GDP) in Cuba in 1998 to that in 1999?
Your answer should be compact. 0.98. What is the ratio of the Value added (% of GDP) in Central Europe in 1998 to that in 2000?
Make the answer very short. 1.05. What is the ratio of the Value added (% of GDP) in Azerbaijan in 1998 to that in 2000?
Keep it short and to the point. 0.8. What is the ratio of the Value added (% of GDP) in Brunei Darussalam in 1998 to that in 2000?
Offer a terse response. 0.81. What is the ratio of the Value added (% of GDP) of Cuba in 1998 to that in 2000?
Provide a succinct answer. 0.9. What is the ratio of the Value added (% of GDP) in Central Europe in 1998 to that in 2001?
Your response must be concise. 1.06. What is the ratio of the Value added (% of GDP) in Azerbaijan in 1998 to that in 2001?
Your answer should be very brief. 0.77. What is the ratio of the Value added (% of GDP) in Brunei Darussalam in 1998 to that in 2001?
Give a very brief answer. 0.86. What is the ratio of the Value added (% of GDP) of Cuba in 1998 to that in 2001?
Provide a succinct answer. 0.96. What is the ratio of the Value added (% of GDP) of Central Europe in 1998 to that in 2002?
Your answer should be compact. 1.08. What is the ratio of the Value added (% of GDP) of Azerbaijan in 1998 to that in 2002?
Your response must be concise. 0.73. What is the ratio of the Value added (% of GDP) of Brunei Darussalam in 1998 to that in 2002?
Keep it short and to the point. 0.85. What is the ratio of the Value added (% of GDP) of Cuba in 1998 to that in 2002?
Your answer should be compact. 1.02. What is the ratio of the Value added (% of GDP) in Central Europe in 1999 to that in 2000?
Keep it short and to the point. 1.02. What is the ratio of the Value added (% of GDP) in Azerbaijan in 1999 to that in 2000?
Ensure brevity in your answer.  0.9. What is the ratio of the Value added (% of GDP) in Brunei Darussalam in 1999 to that in 2000?
Your answer should be very brief. 0.87. What is the ratio of the Value added (% of GDP) of Cuba in 1999 to that in 2000?
Your answer should be very brief. 0.92. What is the ratio of the Value added (% of GDP) in Central Europe in 1999 to that in 2001?
Keep it short and to the point. 1.03. What is the ratio of the Value added (% of GDP) in Azerbaijan in 1999 to that in 2001?
Offer a very short reply. 0.86. What is the ratio of the Value added (% of GDP) in Brunei Darussalam in 1999 to that in 2001?
Your response must be concise. 0.92. What is the ratio of the Value added (% of GDP) of Cuba in 1999 to that in 2001?
Your answer should be compact. 0.98. What is the ratio of the Value added (% of GDP) of Central Europe in 1999 to that in 2002?
Your answer should be compact. 1.05. What is the ratio of the Value added (% of GDP) of Azerbaijan in 1999 to that in 2002?
Provide a short and direct response. 0.81. What is the ratio of the Value added (% of GDP) of Brunei Darussalam in 1999 to that in 2002?
Your answer should be very brief. 0.91. What is the ratio of the Value added (% of GDP) in Cuba in 1999 to that in 2002?
Offer a very short reply. 1.04. What is the ratio of the Value added (% of GDP) in Central Europe in 2000 to that in 2001?
Offer a terse response. 1.01. What is the ratio of the Value added (% of GDP) of Azerbaijan in 2000 to that in 2001?
Your answer should be compact. 0.96. What is the ratio of the Value added (% of GDP) in Brunei Darussalam in 2000 to that in 2001?
Offer a terse response. 1.06. What is the ratio of the Value added (% of GDP) of Cuba in 2000 to that in 2001?
Your answer should be very brief. 1.07. What is the ratio of the Value added (% of GDP) in Central Europe in 2000 to that in 2002?
Your answer should be very brief. 1.03. What is the ratio of the Value added (% of GDP) in Azerbaijan in 2000 to that in 2002?
Your answer should be very brief. 0.9. What is the ratio of the Value added (% of GDP) in Brunei Darussalam in 2000 to that in 2002?
Your response must be concise. 1.05. What is the ratio of the Value added (% of GDP) of Cuba in 2000 to that in 2002?
Provide a succinct answer. 1.14. What is the ratio of the Value added (% of GDP) in Central Europe in 2001 to that in 2002?
Offer a very short reply. 1.02. What is the ratio of the Value added (% of GDP) of Azerbaijan in 2001 to that in 2002?
Offer a very short reply. 0.94. What is the ratio of the Value added (% of GDP) of Cuba in 2001 to that in 2002?
Make the answer very short. 1.06. What is the difference between the highest and the second highest Value added (% of GDP) of Central Europe?
Offer a terse response. 0.21. What is the difference between the highest and the second highest Value added (% of GDP) in Azerbaijan?
Provide a short and direct response. 3. What is the difference between the highest and the second highest Value added (% of GDP) in Brunei Darussalam?
Your response must be concise. 3.01. What is the difference between the highest and the second highest Value added (% of GDP) of Cuba?
Provide a succinct answer. 1.86. What is the difference between the highest and the lowest Value added (% of GDP) of Central Europe?
Provide a succinct answer. 4.14. What is the difference between the highest and the lowest Value added (% of GDP) in Azerbaijan?
Make the answer very short. 13.72. What is the difference between the highest and the lowest Value added (% of GDP) in Brunei Darussalam?
Ensure brevity in your answer.  12.14. What is the difference between the highest and the lowest Value added (% of GDP) in Cuba?
Offer a very short reply. 3.61. 